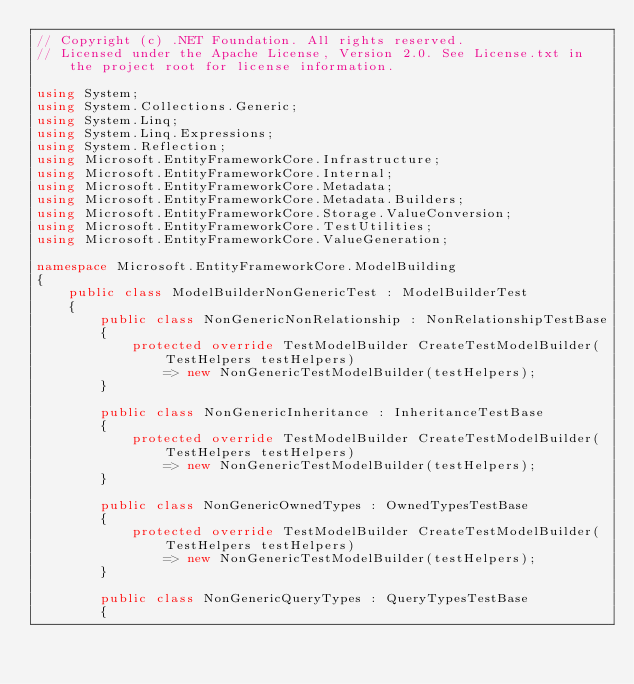<code> <loc_0><loc_0><loc_500><loc_500><_C#_>// Copyright (c) .NET Foundation. All rights reserved.
// Licensed under the Apache License, Version 2.0. See License.txt in the project root for license information.

using System;
using System.Collections.Generic;
using System.Linq;
using System.Linq.Expressions;
using System.Reflection;
using Microsoft.EntityFrameworkCore.Infrastructure;
using Microsoft.EntityFrameworkCore.Internal;
using Microsoft.EntityFrameworkCore.Metadata;
using Microsoft.EntityFrameworkCore.Metadata.Builders;
using Microsoft.EntityFrameworkCore.Storage.ValueConversion;
using Microsoft.EntityFrameworkCore.TestUtilities;
using Microsoft.EntityFrameworkCore.ValueGeneration;

namespace Microsoft.EntityFrameworkCore.ModelBuilding
{
    public class ModelBuilderNonGenericTest : ModelBuilderTest
    {
        public class NonGenericNonRelationship : NonRelationshipTestBase
        {
            protected override TestModelBuilder CreateTestModelBuilder(TestHelpers testHelpers)
                => new NonGenericTestModelBuilder(testHelpers);
        }

        public class NonGenericInheritance : InheritanceTestBase
        {
            protected override TestModelBuilder CreateTestModelBuilder(TestHelpers testHelpers)
                => new NonGenericTestModelBuilder(testHelpers);
        }

        public class NonGenericOwnedTypes : OwnedTypesTestBase
        {
            protected override TestModelBuilder CreateTestModelBuilder(TestHelpers testHelpers)
                => new NonGenericTestModelBuilder(testHelpers);
        }

        public class NonGenericQueryTypes : QueryTypesTestBase
        {</code> 